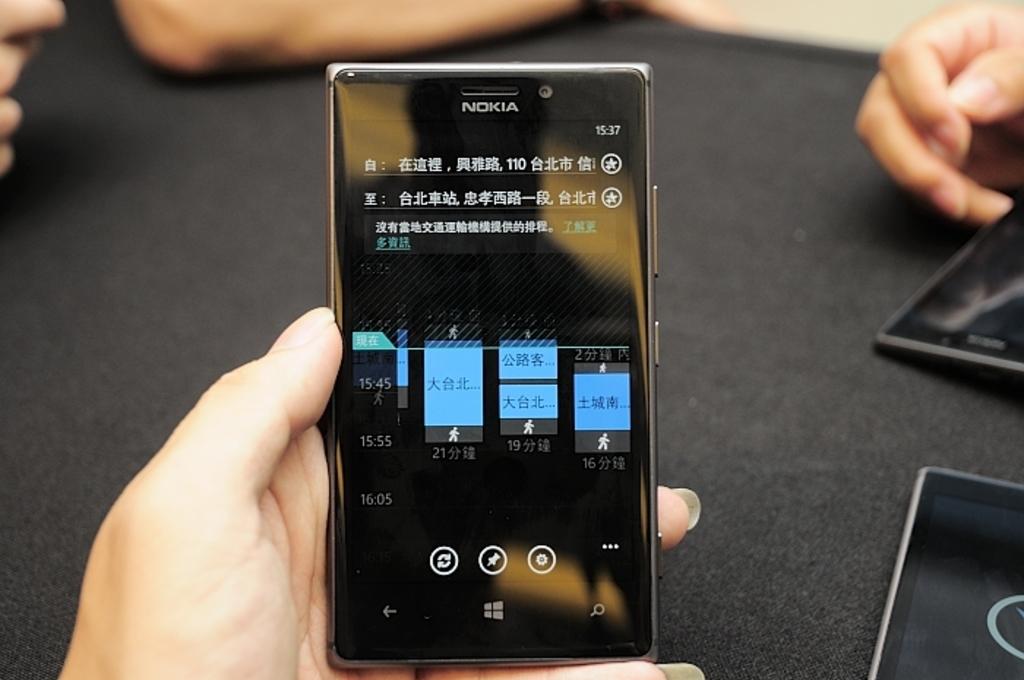What company logo is on the top of the smartphone?
Provide a succinct answer. Nokia. 